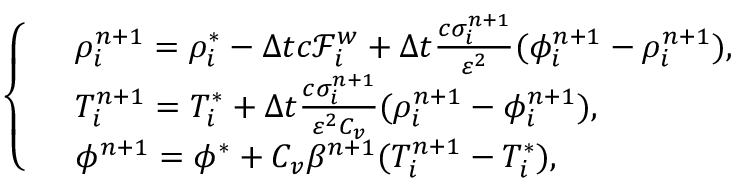Convert formula to latex. <formula><loc_0><loc_0><loc_500><loc_500>\left \{ \begin{array} { r l } & { \rho _ { i } ^ { n + 1 } = \rho _ { i } ^ { * } - \Delta t c \mathcal { F } _ { i } ^ { w } + \Delta t \frac { c \sigma _ { i } ^ { n + 1 } } { \varepsilon ^ { 2 } } ( \phi _ { i } ^ { n + 1 } - \rho _ { i } ^ { n + 1 } ) , } \\ & { T _ { i } ^ { n + 1 } = T _ { i } ^ { * } + \Delta t \frac { c \sigma _ { i } ^ { n + 1 } } { \varepsilon ^ { 2 } C _ { v } } ( \rho _ { i } ^ { n + 1 } - \phi _ { i } ^ { n + 1 } ) , } \\ & { \phi ^ { n + 1 } = \phi ^ { * } + C _ { v } \beta ^ { n + 1 } ( T _ { i } ^ { n + 1 } - T _ { i } ^ { * } ) , } \end{array}</formula> 